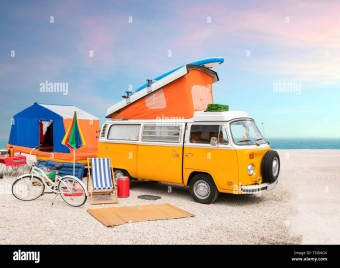Can you describe the setting in which the camper van is located? The camper van is set against a scenic backdrop that combines elements of both the beach and a vast, clear sky, likely near the coastline. The ground appears to be paved, with a rug laid out in front of the van, hinting at a prepared and comfortable outdoor living space. 